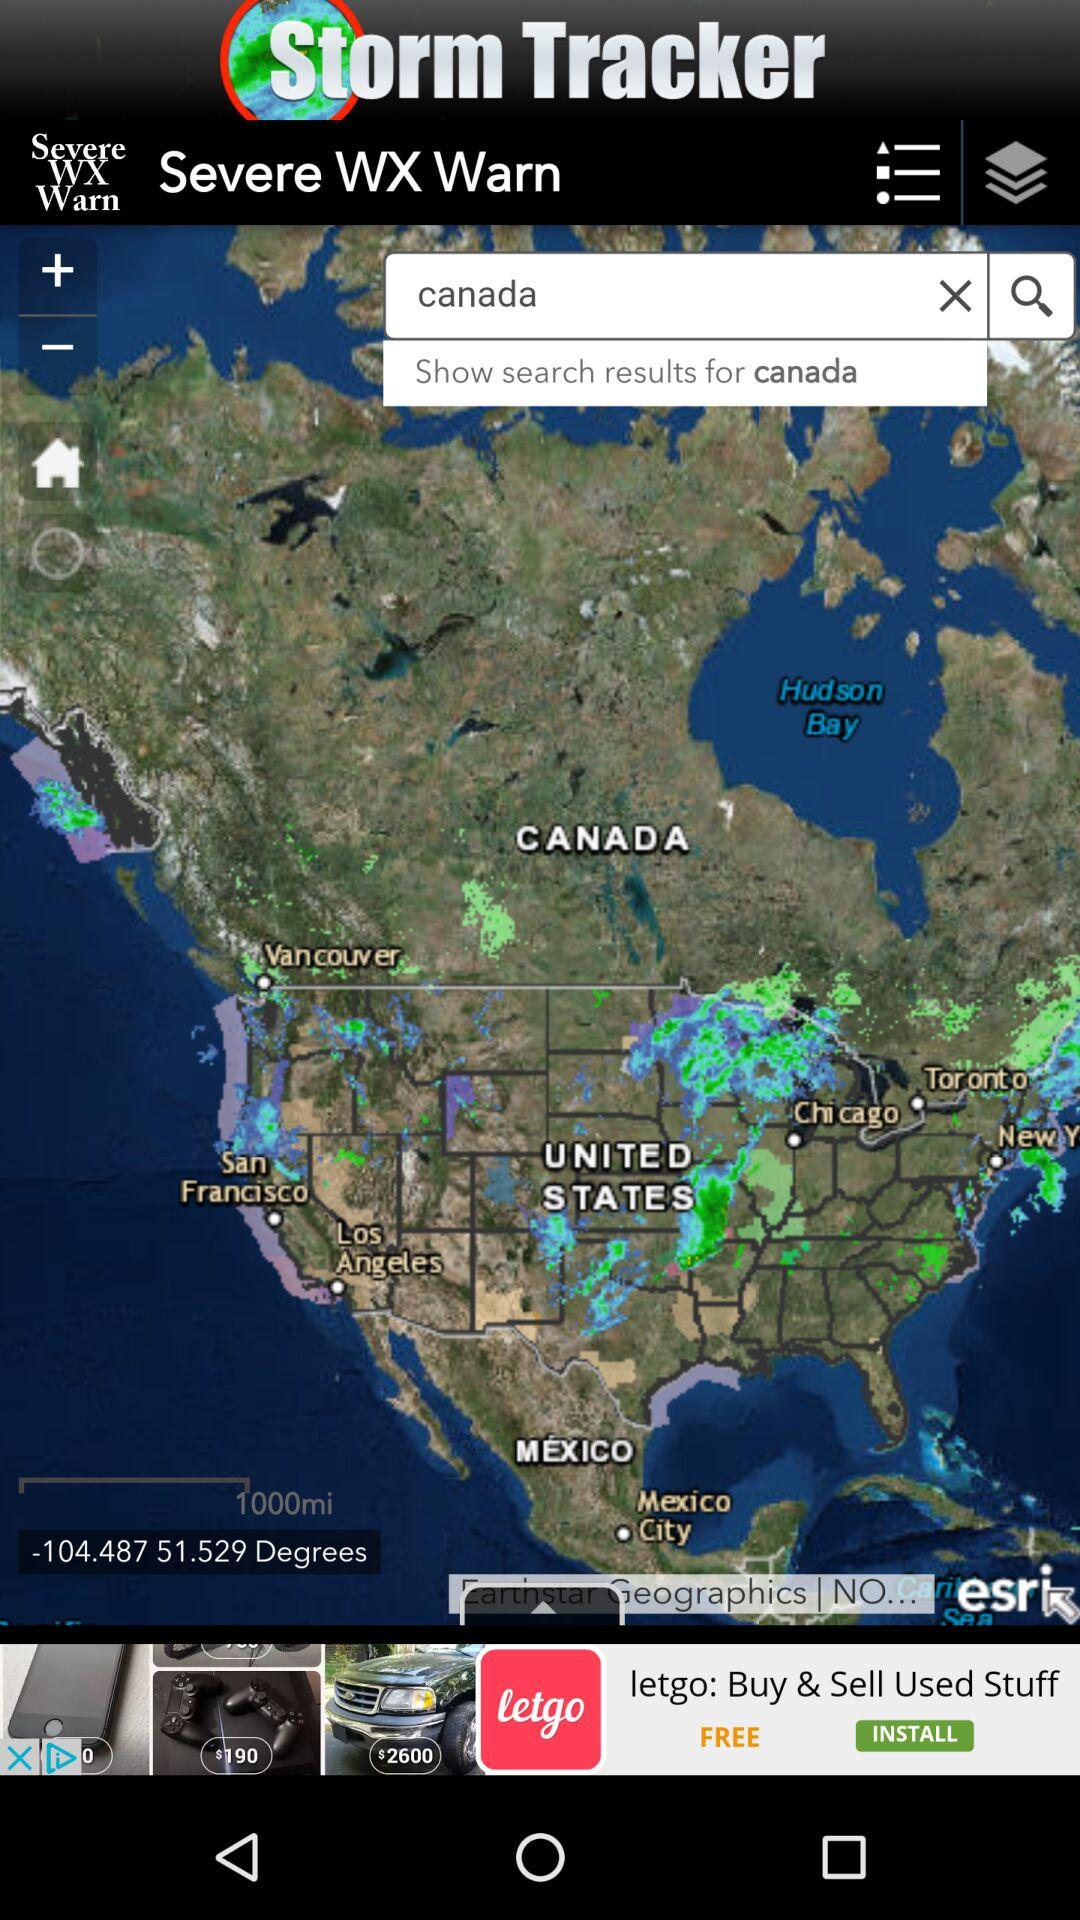What is the application name? The application name is "Storm Tracker". 